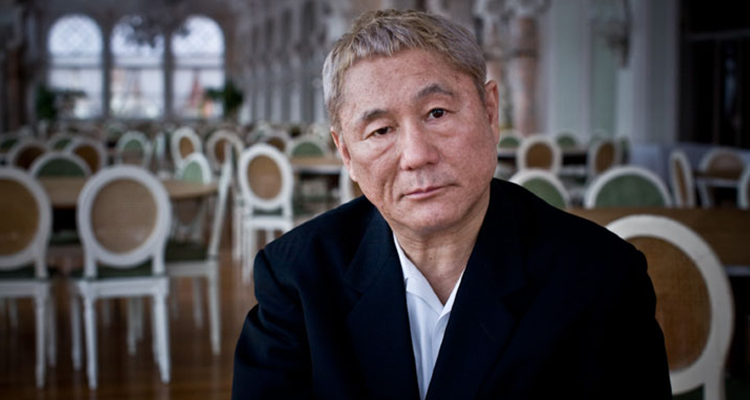What does the expression on the man's face convey? The man's expression suggests a mixture of severity and introspection. There appears to be a depth of emotion behind his gaze, perhaps indicative of personal reflection or a response to a deep conversation or thought. 